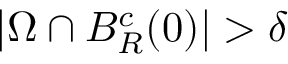Convert formula to latex. <formula><loc_0><loc_0><loc_500><loc_500>| \Omega \cap B _ { R } ^ { c } ( 0 ) | > \delta</formula> 